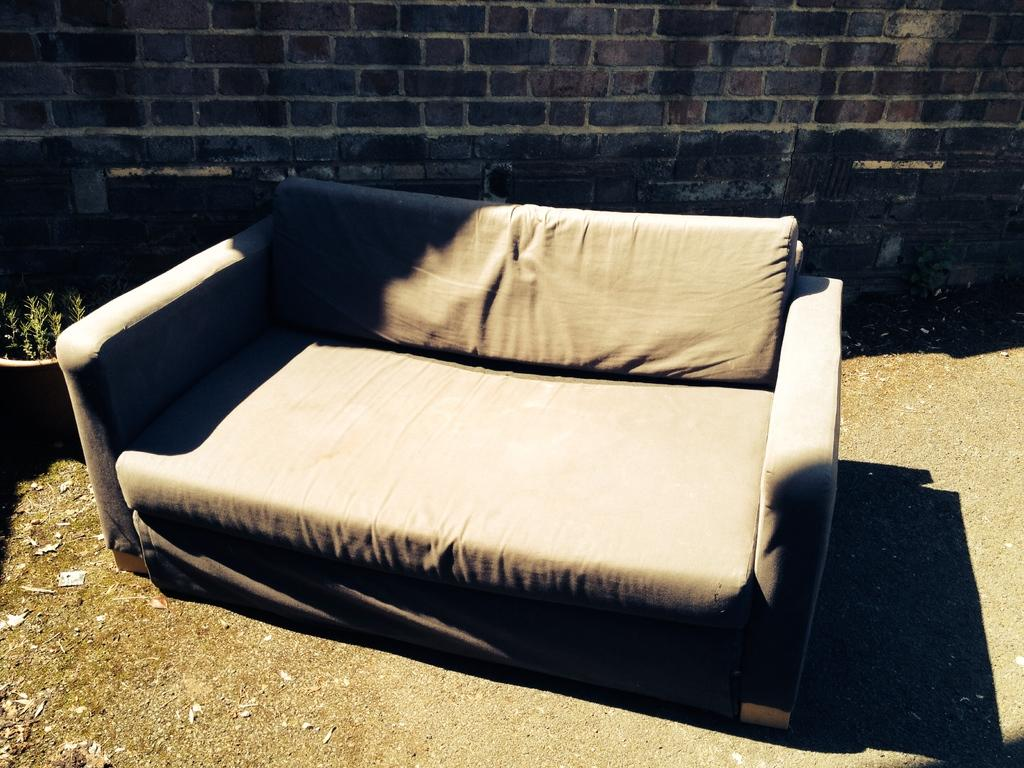What type of furniture is in the image? There is a sofa in the image. What color is the sofa? The sofa is grey in color. Where is the sofa located? The sofa is placed outside. What can be seen on the left side of the image? There is a flower pot on the left side of the image. What type of advice can be seen written on the sofa in the image? There is no advice written on the sofa in the image; it is a piece of furniture and not a surface for writing. 